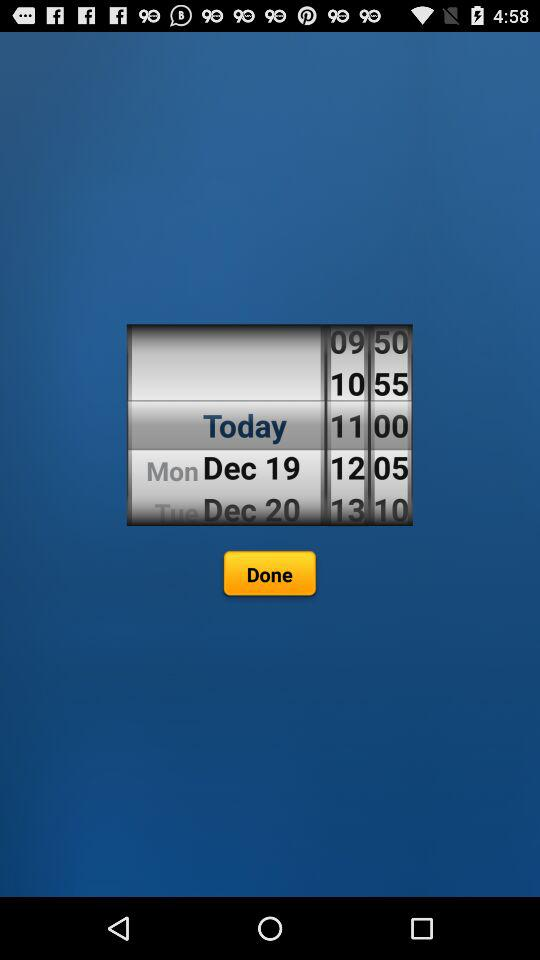How many minutes after 10:55 is 11:00?
Answer the question using a single word or phrase. 5 